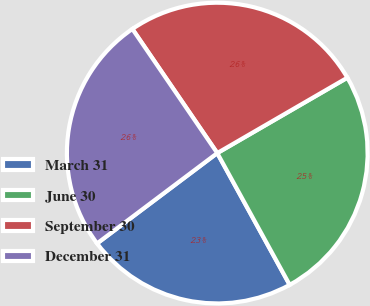Convert chart to OTSL. <chart><loc_0><loc_0><loc_500><loc_500><pie_chart><fcel>March 31<fcel>June 30<fcel>September 30<fcel>December 31<nl><fcel>22.74%<fcel>25.36%<fcel>26.19%<fcel>25.71%<nl></chart> 